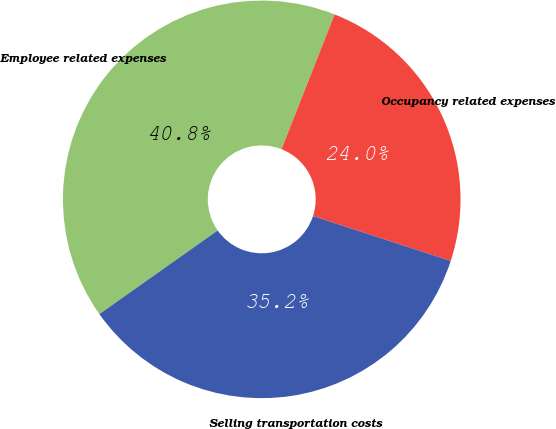Convert chart to OTSL. <chart><loc_0><loc_0><loc_500><loc_500><pie_chart><fcel>Employee related expenses<fcel>Occupancy related expenses<fcel>Selling transportation costs<nl><fcel>40.77%<fcel>24.04%<fcel>35.19%<nl></chart> 